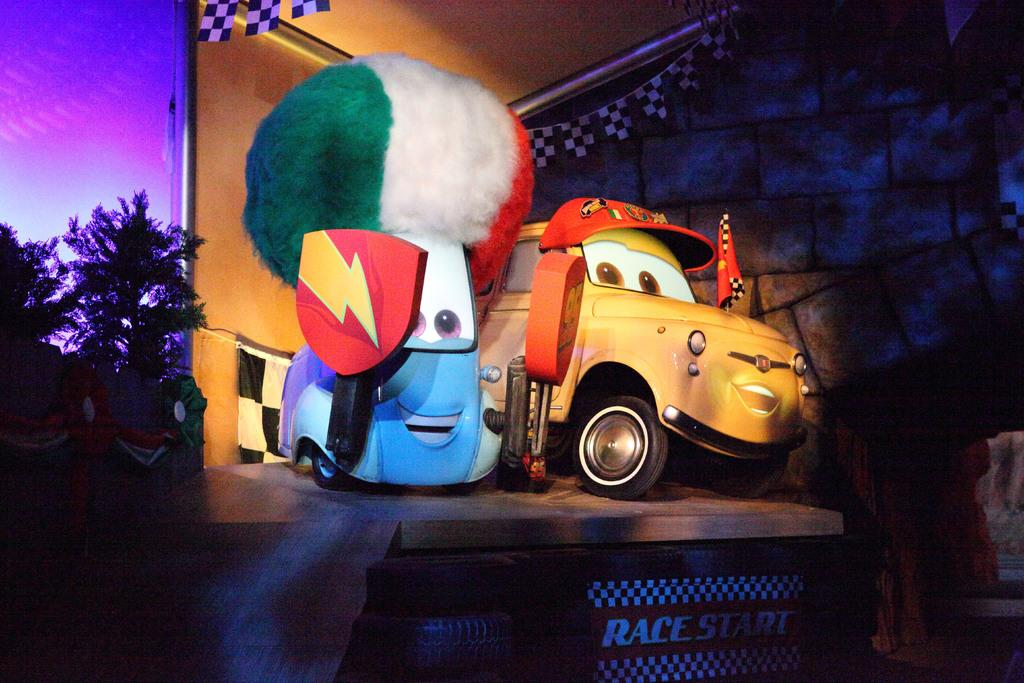What objects are in the middle of the picture? There are toy cars in the middle of the picture. What type of surface are the toy cars placed on? The toy cars are on a wooden floor. What can be seen on the left side of the image? There are trees on the left side of the image. What is visible in the background of the image? There is a wall in the background of the image. What type of division is taking place in the image? There is no division taking place in the image; it features toy cars on a wooden floor with trees and a wall in the background. 